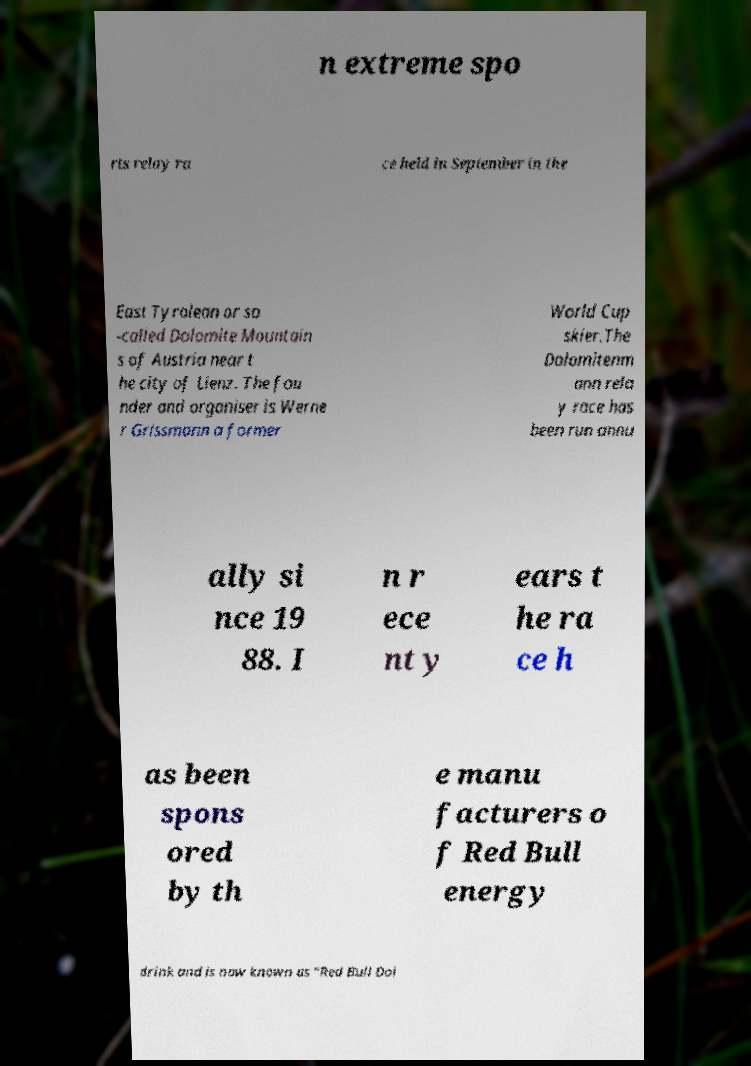For documentation purposes, I need the text within this image transcribed. Could you provide that? n extreme spo rts relay ra ce held in September in the East Tyrolean or so -called Dolomite Mountain s of Austria near t he city of Lienz. The fou nder and organiser is Werne r Grissmann a former World Cup skier.The Dolomitenm ann rela y race has been run annu ally si nce 19 88. I n r ece nt y ears t he ra ce h as been spons ored by th e manu facturers o f Red Bull energy drink and is now known as "Red Bull Dol 